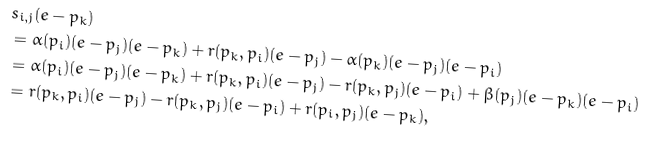Convert formula to latex. <formula><loc_0><loc_0><loc_500><loc_500>& s _ { i , j } ( e - p _ { k } ) \\ & = \alpha ( p _ { i } ) ( e - p _ { j } ) ( e - p _ { k } ) + r ( p _ { k } , p _ { i } ) ( e - p _ { j } ) - \alpha ( p _ { k } ) ( e - p _ { j } ) ( e - p _ { i } ) \\ & = \alpha ( p _ { i } ) ( e - p _ { j } ) ( e - p _ { k } ) + r ( p _ { k } , p _ { i } ) ( e - p _ { j } ) - r ( p _ { k } , p _ { j } ) ( e - p _ { i } ) + \beta ( p _ { j } ) ( e - p _ { k } ) ( e - p _ { i } ) \\ & = r ( p _ { k } , p _ { i } ) ( e - p _ { j } ) - r ( p _ { k } , p _ { j } ) ( e - p _ { i } ) + r ( p _ { i } , p _ { j } ) ( e - p _ { k } ) ,</formula> 